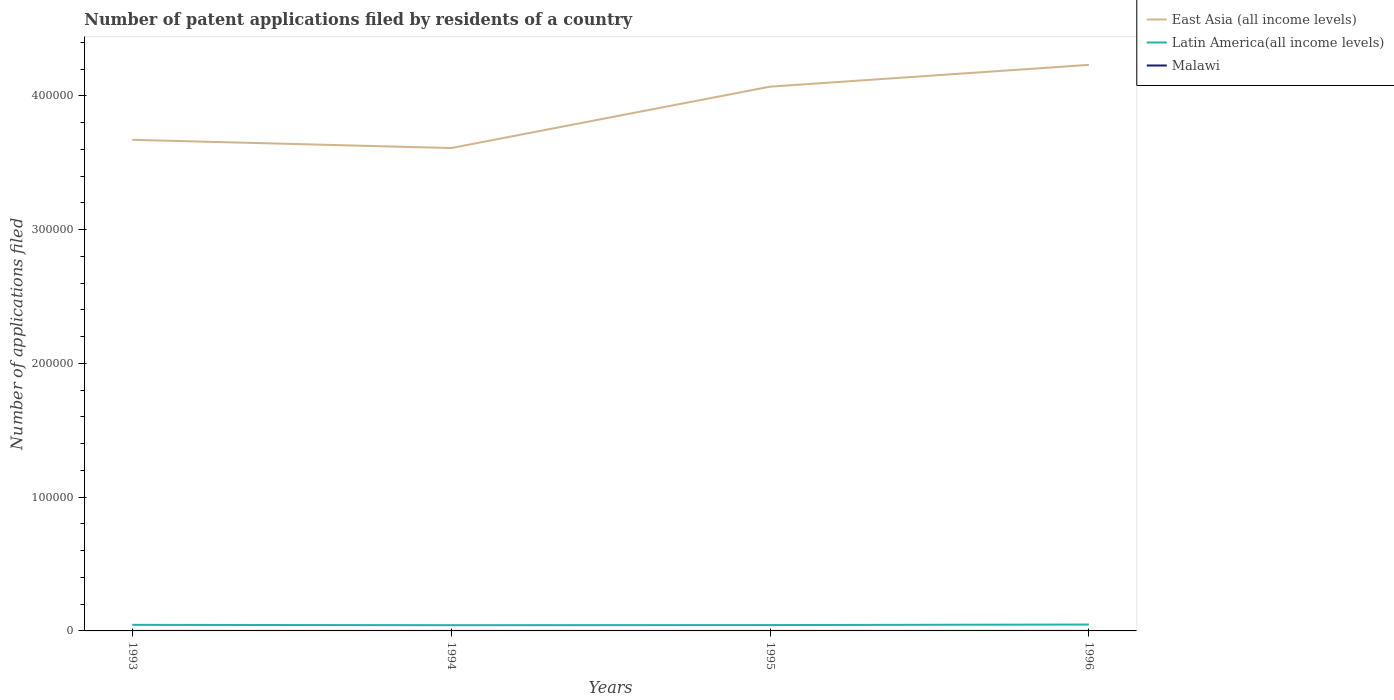How many different coloured lines are there?
Your response must be concise. 3. Across all years, what is the maximum number of applications filed in East Asia (all income levels)?
Ensure brevity in your answer.  3.61e+05. In which year was the number of applications filed in East Asia (all income levels) maximum?
Offer a very short reply. 1994. What is the total number of applications filed in Latin America(all income levels) in the graph?
Make the answer very short. 148. What is the difference between the highest and the second highest number of applications filed in East Asia (all income levels)?
Your response must be concise. 6.22e+04. What is the difference between the highest and the lowest number of applications filed in Latin America(all income levels)?
Make the answer very short. 2. How many years are there in the graph?
Provide a short and direct response. 4. What is the difference between two consecutive major ticks on the Y-axis?
Give a very brief answer. 1.00e+05. Are the values on the major ticks of Y-axis written in scientific E-notation?
Your answer should be very brief. No. Does the graph contain any zero values?
Your answer should be compact. No. Does the graph contain grids?
Your answer should be very brief. No. How are the legend labels stacked?
Ensure brevity in your answer.  Vertical. What is the title of the graph?
Offer a very short reply. Number of patent applications filed by residents of a country. What is the label or title of the X-axis?
Your answer should be compact. Years. What is the label or title of the Y-axis?
Your response must be concise. Number of applications filed. What is the Number of applications filed in East Asia (all income levels) in 1993?
Give a very brief answer. 3.67e+05. What is the Number of applications filed in Latin America(all income levels) in 1993?
Give a very brief answer. 4528. What is the Number of applications filed of East Asia (all income levels) in 1994?
Keep it short and to the point. 3.61e+05. What is the Number of applications filed of Latin America(all income levels) in 1994?
Your answer should be compact. 4289. What is the Number of applications filed of Malawi in 1994?
Your answer should be very brief. 1. What is the Number of applications filed of East Asia (all income levels) in 1995?
Give a very brief answer. 4.07e+05. What is the Number of applications filed of Latin America(all income levels) in 1995?
Offer a terse response. 4380. What is the Number of applications filed of Malawi in 1995?
Ensure brevity in your answer.  1. What is the Number of applications filed in East Asia (all income levels) in 1996?
Ensure brevity in your answer.  4.23e+05. What is the Number of applications filed of Latin America(all income levels) in 1996?
Your response must be concise. 4783. What is the Number of applications filed in Malawi in 1996?
Your answer should be very brief. 2. Across all years, what is the maximum Number of applications filed in East Asia (all income levels)?
Your response must be concise. 4.23e+05. Across all years, what is the maximum Number of applications filed of Latin America(all income levels)?
Your response must be concise. 4783. Across all years, what is the minimum Number of applications filed in East Asia (all income levels)?
Your answer should be very brief. 3.61e+05. Across all years, what is the minimum Number of applications filed in Latin America(all income levels)?
Your answer should be very brief. 4289. Across all years, what is the minimum Number of applications filed of Malawi?
Your answer should be compact. 1. What is the total Number of applications filed of East Asia (all income levels) in the graph?
Provide a succinct answer. 1.56e+06. What is the total Number of applications filed of Latin America(all income levels) in the graph?
Your answer should be compact. 1.80e+04. What is the difference between the Number of applications filed of East Asia (all income levels) in 1993 and that in 1994?
Your response must be concise. 6149. What is the difference between the Number of applications filed in Latin America(all income levels) in 1993 and that in 1994?
Offer a terse response. 239. What is the difference between the Number of applications filed in Malawi in 1993 and that in 1994?
Give a very brief answer. 2. What is the difference between the Number of applications filed of East Asia (all income levels) in 1993 and that in 1995?
Offer a terse response. -3.98e+04. What is the difference between the Number of applications filed in Latin America(all income levels) in 1993 and that in 1995?
Your answer should be compact. 148. What is the difference between the Number of applications filed in East Asia (all income levels) in 1993 and that in 1996?
Offer a terse response. -5.60e+04. What is the difference between the Number of applications filed in Latin America(all income levels) in 1993 and that in 1996?
Offer a terse response. -255. What is the difference between the Number of applications filed in East Asia (all income levels) in 1994 and that in 1995?
Offer a terse response. -4.59e+04. What is the difference between the Number of applications filed of Latin America(all income levels) in 1994 and that in 1995?
Your answer should be compact. -91. What is the difference between the Number of applications filed in Malawi in 1994 and that in 1995?
Make the answer very short. 0. What is the difference between the Number of applications filed in East Asia (all income levels) in 1994 and that in 1996?
Offer a terse response. -6.22e+04. What is the difference between the Number of applications filed of Latin America(all income levels) in 1994 and that in 1996?
Your answer should be compact. -494. What is the difference between the Number of applications filed of Malawi in 1994 and that in 1996?
Ensure brevity in your answer.  -1. What is the difference between the Number of applications filed in East Asia (all income levels) in 1995 and that in 1996?
Your answer should be compact. -1.63e+04. What is the difference between the Number of applications filed of Latin America(all income levels) in 1995 and that in 1996?
Provide a succinct answer. -403. What is the difference between the Number of applications filed of East Asia (all income levels) in 1993 and the Number of applications filed of Latin America(all income levels) in 1994?
Make the answer very short. 3.63e+05. What is the difference between the Number of applications filed of East Asia (all income levels) in 1993 and the Number of applications filed of Malawi in 1994?
Provide a succinct answer. 3.67e+05. What is the difference between the Number of applications filed of Latin America(all income levels) in 1993 and the Number of applications filed of Malawi in 1994?
Offer a very short reply. 4527. What is the difference between the Number of applications filed in East Asia (all income levels) in 1993 and the Number of applications filed in Latin America(all income levels) in 1995?
Provide a short and direct response. 3.63e+05. What is the difference between the Number of applications filed in East Asia (all income levels) in 1993 and the Number of applications filed in Malawi in 1995?
Provide a short and direct response. 3.67e+05. What is the difference between the Number of applications filed of Latin America(all income levels) in 1993 and the Number of applications filed of Malawi in 1995?
Provide a short and direct response. 4527. What is the difference between the Number of applications filed of East Asia (all income levels) in 1993 and the Number of applications filed of Latin America(all income levels) in 1996?
Provide a short and direct response. 3.62e+05. What is the difference between the Number of applications filed of East Asia (all income levels) in 1993 and the Number of applications filed of Malawi in 1996?
Your answer should be compact. 3.67e+05. What is the difference between the Number of applications filed of Latin America(all income levels) in 1993 and the Number of applications filed of Malawi in 1996?
Make the answer very short. 4526. What is the difference between the Number of applications filed in East Asia (all income levels) in 1994 and the Number of applications filed in Latin America(all income levels) in 1995?
Give a very brief answer. 3.57e+05. What is the difference between the Number of applications filed in East Asia (all income levels) in 1994 and the Number of applications filed in Malawi in 1995?
Give a very brief answer. 3.61e+05. What is the difference between the Number of applications filed in Latin America(all income levels) in 1994 and the Number of applications filed in Malawi in 1995?
Your answer should be compact. 4288. What is the difference between the Number of applications filed of East Asia (all income levels) in 1994 and the Number of applications filed of Latin America(all income levels) in 1996?
Provide a short and direct response. 3.56e+05. What is the difference between the Number of applications filed in East Asia (all income levels) in 1994 and the Number of applications filed in Malawi in 1996?
Keep it short and to the point. 3.61e+05. What is the difference between the Number of applications filed of Latin America(all income levels) in 1994 and the Number of applications filed of Malawi in 1996?
Ensure brevity in your answer.  4287. What is the difference between the Number of applications filed in East Asia (all income levels) in 1995 and the Number of applications filed in Latin America(all income levels) in 1996?
Your response must be concise. 4.02e+05. What is the difference between the Number of applications filed of East Asia (all income levels) in 1995 and the Number of applications filed of Malawi in 1996?
Give a very brief answer. 4.07e+05. What is the difference between the Number of applications filed in Latin America(all income levels) in 1995 and the Number of applications filed in Malawi in 1996?
Ensure brevity in your answer.  4378. What is the average Number of applications filed in East Asia (all income levels) per year?
Your response must be concise. 3.90e+05. What is the average Number of applications filed in Latin America(all income levels) per year?
Your response must be concise. 4495. In the year 1993, what is the difference between the Number of applications filed in East Asia (all income levels) and Number of applications filed in Latin America(all income levels)?
Provide a succinct answer. 3.63e+05. In the year 1993, what is the difference between the Number of applications filed in East Asia (all income levels) and Number of applications filed in Malawi?
Ensure brevity in your answer.  3.67e+05. In the year 1993, what is the difference between the Number of applications filed of Latin America(all income levels) and Number of applications filed of Malawi?
Offer a very short reply. 4525. In the year 1994, what is the difference between the Number of applications filed in East Asia (all income levels) and Number of applications filed in Latin America(all income levels)?
Your answer should be compact. 3.57e+05. In the year 1994, what is the difference between the Number of applications filed of East Asia (all income levels) and Number of applications filed of Malawi?
Your answer should be compact. 3.61e+05. In the year 1994, what is the difference between the Number of applications filed in Latin America(all income levels) and Number of applications filed in Malawi?
Give a very brief answer. 4288. In the year 1995, what is the difference between the Number of applications filed in East Asia (all income levels) and Number of applications filed in Latin America(all income levels)?
Make the answer very short. 4.03e+05. In the year 1995, what is the difference between the Number of applications filed of East Asia (all income levels) and Number of applications filed of Malawi?
Give a very brief answer. 4.07e+05. In the year 1995, what is the difference between the Number of applications filed of Latin America(all income levels) and Number of applications filed of Malawi?
Your answer should be compact. 4379. In the year 1996, what is the difference between the Number of applications filed of East Asia (all income levels) and Number of applications filed of Latin America(all income levels)?
Provide a succinct answer. 4.18e+05. In the year 1996, what is the difference between the Number of applications filed of East Asia (all income levels) and Number of applications filed of Malawi?
Offer a very short reply. 4.23e+05. In the year 1996, what is the difference between the Number of applications filed of Latin America(all income levels) and Number of applications filed of Malawi?
Offer a very short reply. 4781. What is the ratio of the Number of applications filed in Latin America(all income levels) in 1993 to that in 1994?
Your response must be concise. 1.06. What is the ratio of the Number of applications filed of Malawi in 1993 to that in 1994?
Give a very brief answer. 3. What is the ratio of the Number of applications filed of East Asia (all income levels) in 1993 to that in 1995?
Your answer should be compact. 0.9. What is the ratio of the Number of applications filed of Latin America(all income levels) in 1993 to that in 1995?
Ensure brevity in your answer.  1.03. What is the ratio of the Number of applications filed of Malawi in 1993 to that in 1995?
Provide a succinct answer. 3. What is the ratio of the Number of applications filed of East Asia (all income levels) in 1993 to that in 1996?
Make the answer very short. 0.87. What is the ratio of the Number of applications filed of Latin America(all income levels) in 1993 to that in 1996?
Provide a short and direct response. 0.95. What is the ratio of the Number of applications filed in Malawi in 1993 to that in 1996?
Offer a very short reply. 1.5. What is the ratio of the Number of applications filed of East Asia (all income levels) in 1994 to that in 1995?
Ensure brevity in your answer.  0.89. What is the ratio of the Number of applications filed of Latin America(all income levels) in 1994 to that in 1995?
Offer a very short reply. 0.98. What is the ratio of the Number of applications filed of Malawi in 1994 to that in 1995?
Give a very brief answer. 1. What is the ratio of the Number of applications filed in East Asia (all income levels) in 1994 to that in 1996?
Provide a short and direct response. 0.85. What is the ratio of the Number of applications filed in Latin America(all income levels) in 1994 to that in 1996?
Keep it short and to the point. 0.9. What is the ratio of the Number of applications filed of East Asia (all income levels) in 1995 to that in 1996?
Provide a succinct answer. 0.96. What is the ratio of the Number of applications filed in Latin America(all income levels) in 1995 to that in 1996?
Keep it short and to the point. 0.92. What is the ratio of the Number of applications filed of Malawi in 1995 to that in 1996?
Provide a succinct answer. 0.5. What is the difference between the highest and the second highest Number of applications filed of East Asia (all income levels)?
Your answer should be compact. 1.63e+04. What is the difference between the highest and the second highest Number of applications filed of Latin America(all income levels)?
Provide a short and direct response. 255. What is the difference between the highest and the lowest Number of applications filed in East Asia (all income levels)?
Make the answer very short. 6.22e+04. What is the difference between the highest and the lowest Number of applications filed of Latin America(all income levels)?
Keep it short and to the point. 494. What is the difference between the highest and the lowest Number of applications filed in Malawi?
Your response must be concise. 2. 